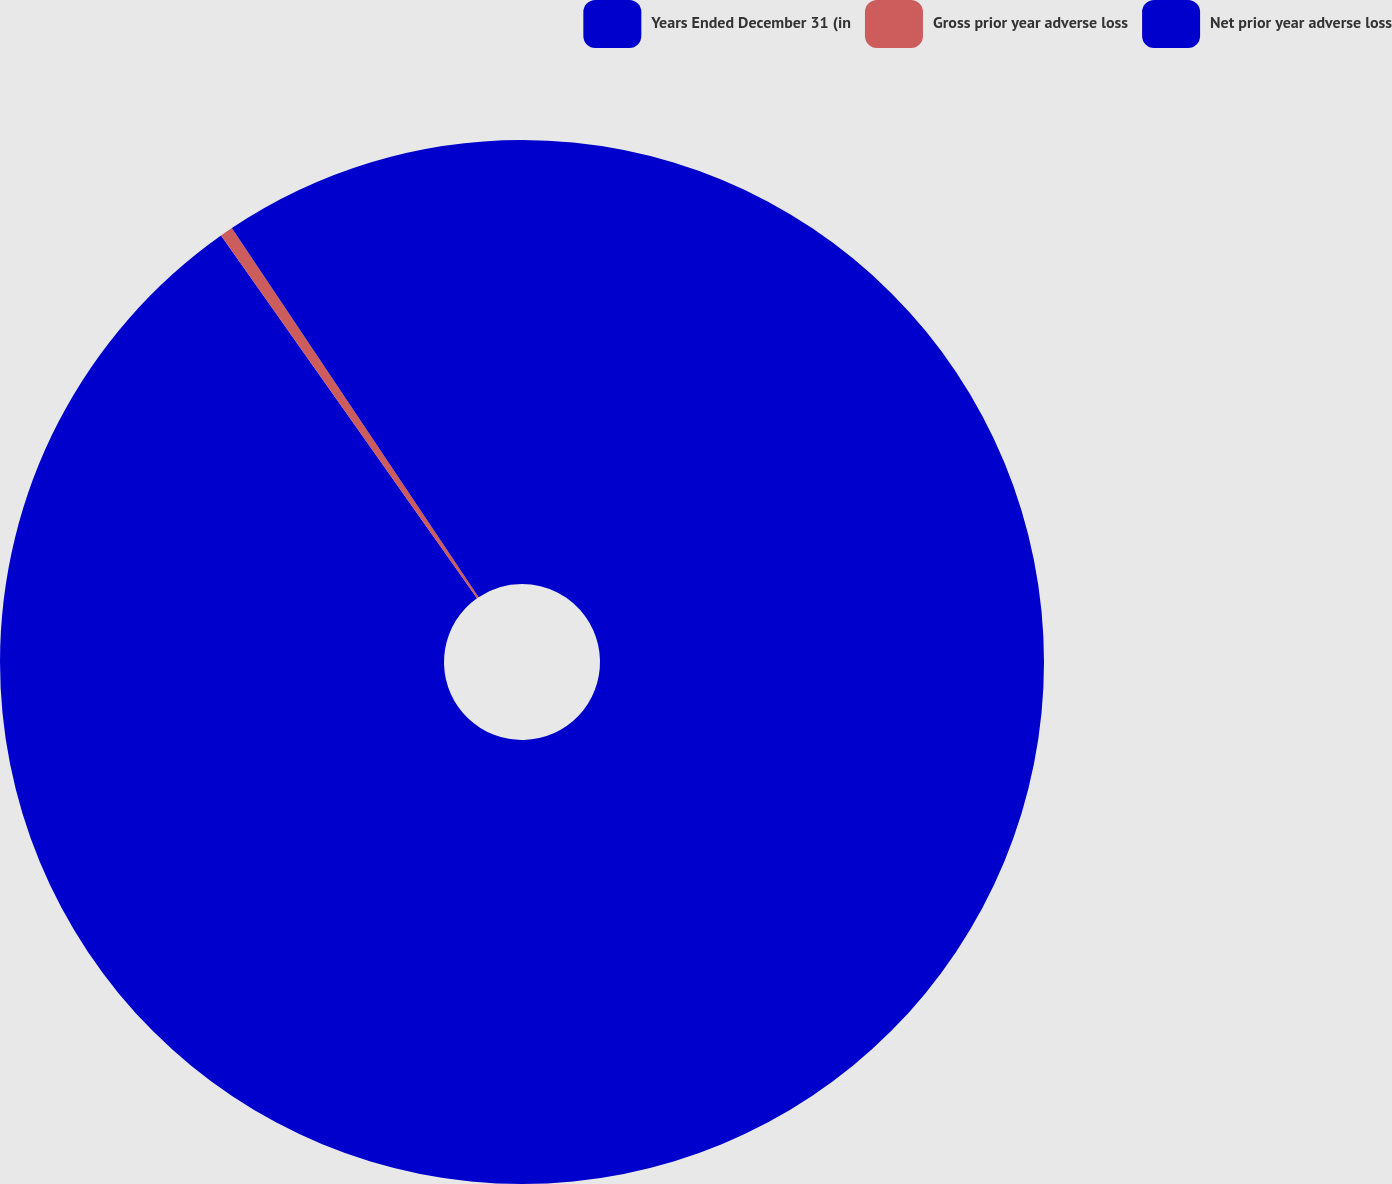Convert chart. <chart><loc_0><loc_0><loc_500><loc_500><pie_chart><fcel>Years Ended December 31 (in<fcel>Gross prior year adverse loss<fcel>Net prior year adverse loss<nl><fcel>90.21%<fcel>0.4%<fcel>9.38%<nl></chart> 